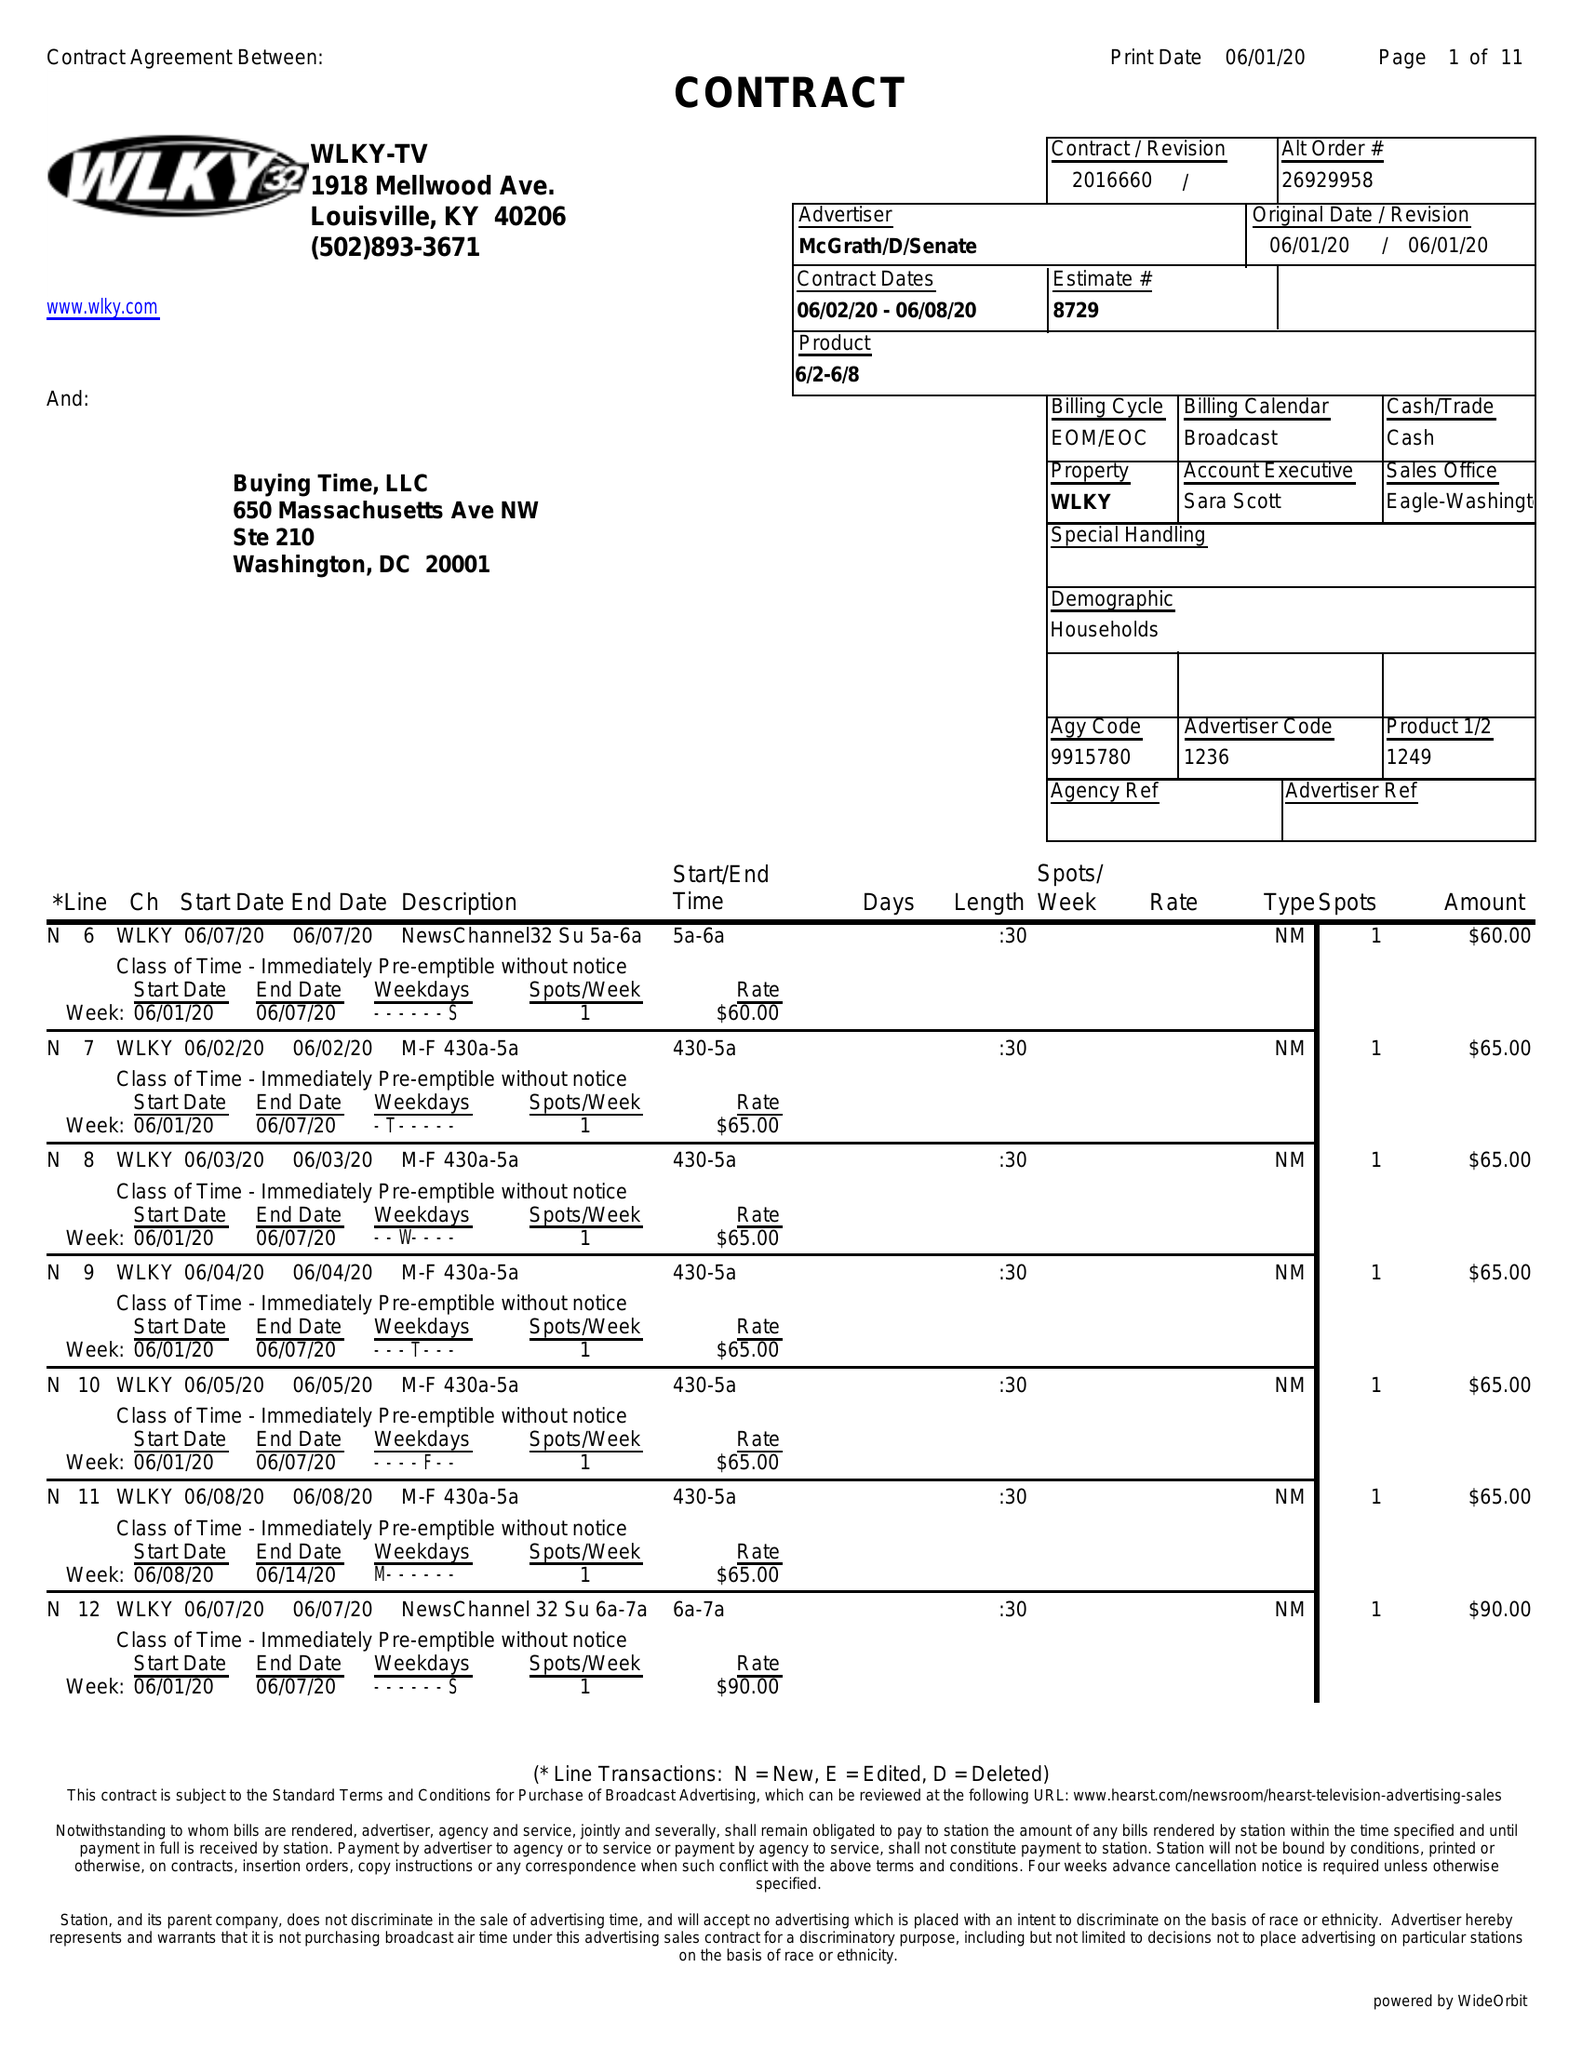What is the value for the flight_to?
Answer the question using a single word or phrase. 06/08/20 